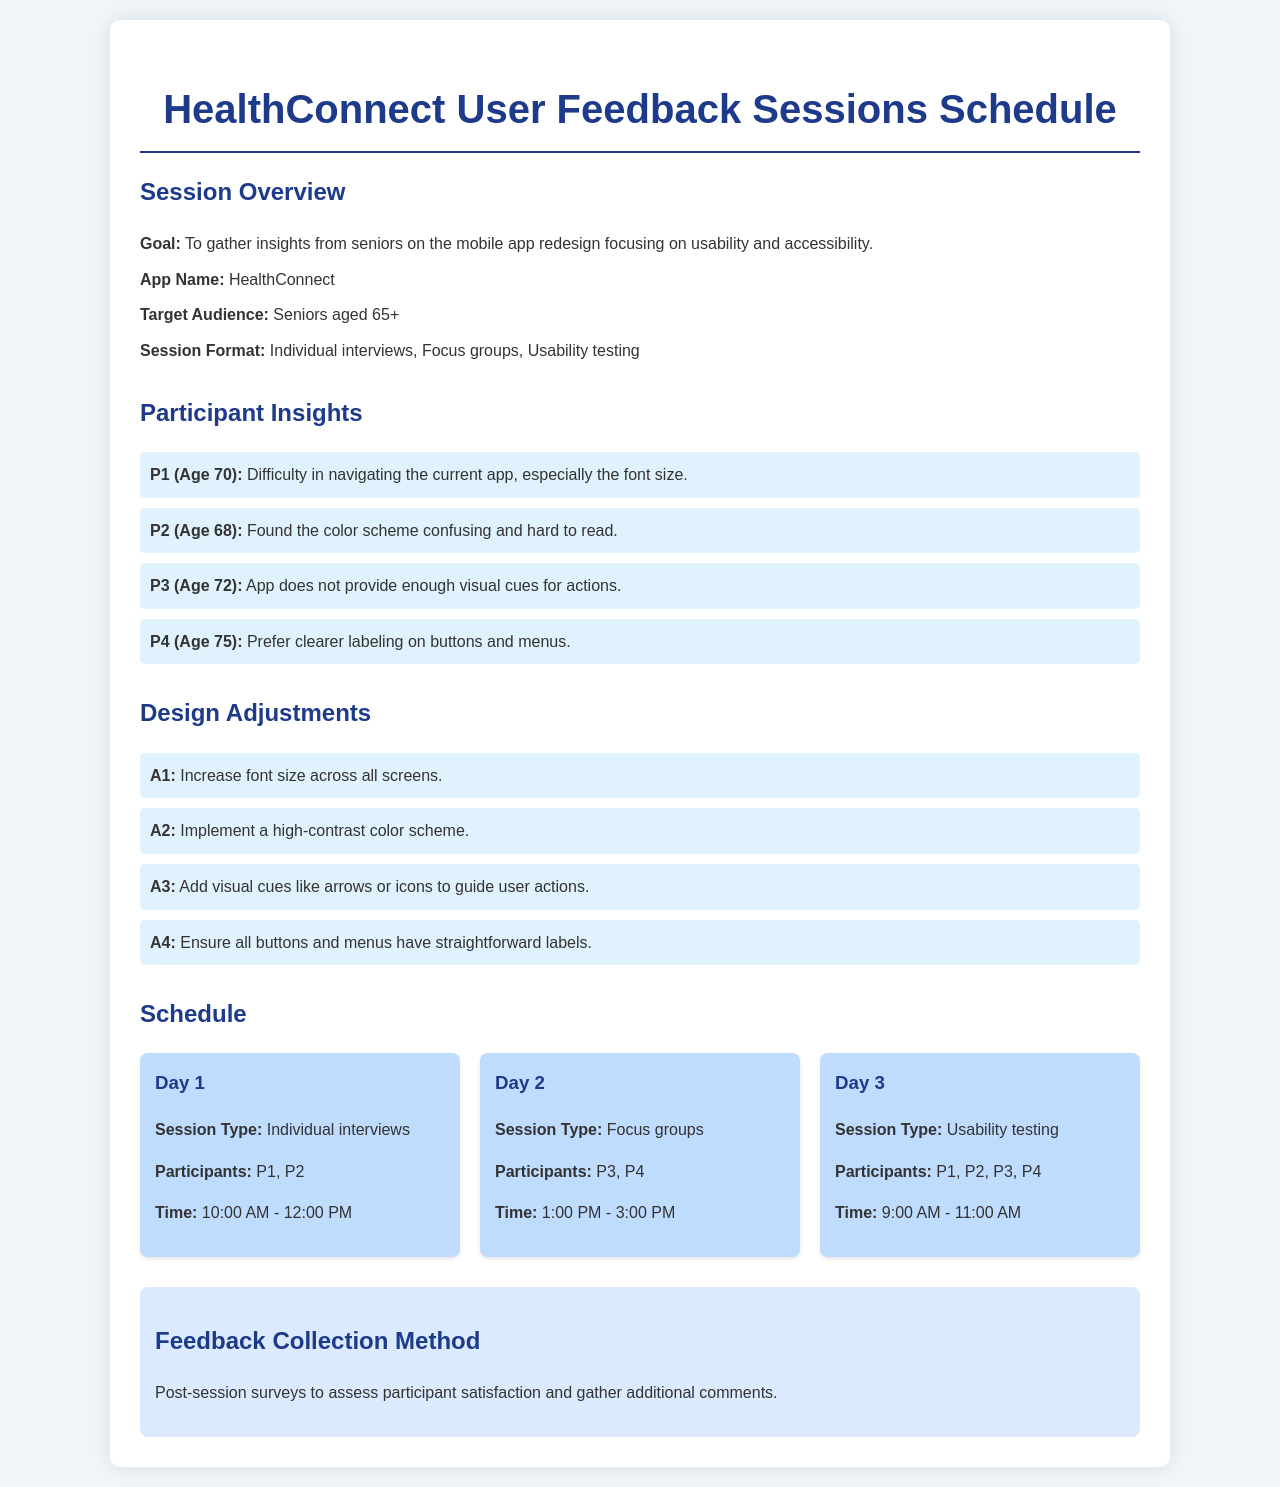What is the goal of the sessions? The goal of the sessions is to gather insights from seniors on the mobile app redesign focusing on usability and accessibility.
Answer: To gather insights from seniors on the mobile app redesign focusing on usability and accessibility Who are the participants in the usability testing session? The usability testing session includes participants from all the previous sessions.
Answer: P1, P2, P3, P4 What is the age of participant P2? The age of participant P2 is specified in the insights section.
Answer: 68 What does the color scheme need to improve according to participant P2? Participant P2 found the color scheme confusing and hard to read, indicating a need for improvements.
Answer: Confusing and hard to read Which design adjustment involves labeling? The design adjustment regarding labeling is stated in the document under the design adjustments section.
Answer: Ensure all buttons and menus have straightforward labels What is the session type for Day 2? The session type for Day 2 is mentioned in the schedule section.
Answer: Focus groups What time does the Day 1 session start? The start time for Day 1 is provided in the session schedule.
Answer: 10:00 AM How many participants were involved in Day 1? The number of participants involved in Day 1 can be counted based on the information in the session schedule.
Answer: 2 What is the feedback collection method mentioned in the document? The document specifies the method of feedback collection employed after the sessions, which is essential for assessing satisfaction.
Answer: Post-session surveys 